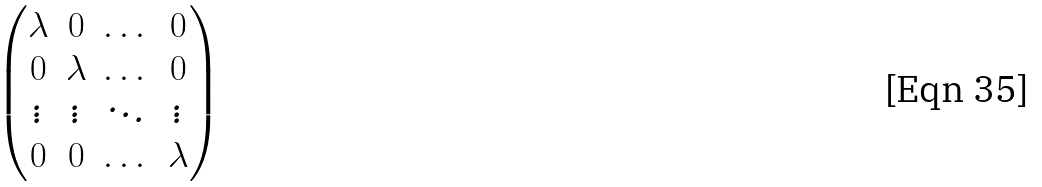<formula> <loc_0><loc_0><loc_500><loc_500>\begin{pmatrix} \lambda & 0 & \dots & 0 \\ 0 & \lambda & \dots & 0 \\ \vdots & \vdots & \ddots & \vdots \\ 0 & 0 & \dots & \lambda \\ \end{pmatrix}</formula> 